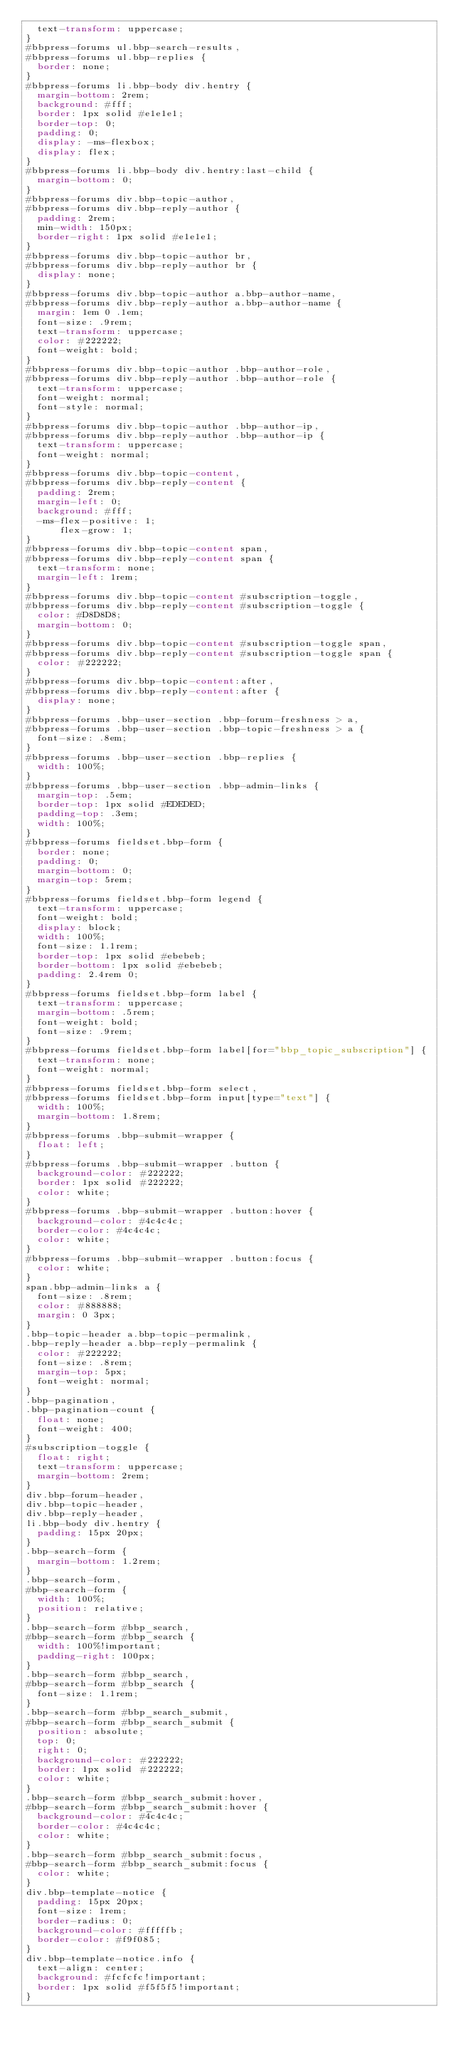<code> <loc_0><loc_0><loc_500><loc_500><_CSS_>  text-transform: uppercase;
}
#bbpress-forums ul.bbp-search-results,
#bbpress-forums ul.bbp-replies {
  border: none;
}
#bbpress-forums li.bbp-body div.hentry {
  margin-bottom: 2rem;
  background: #fff;
  border: 1px solid #e1e1e1;
  border-top: 0;
  padding: 0;
  display: -ms-flexbox;
  display: flex;
}
#bbpress-forums li.bbp-body div.hentry:last-child {
  margin-bottom: 0;
}
#bbpress-forums div.bbp-topic-author,
#bbpress-forums div.bbp-reply-author {
  padding: 2rem;
  min-width: 150px;
  border-right: 1px solid #e1e1e1;
}
#bbpress-forums div.bbp-topic-author br,
#bbpress-forums div.bbp-reply-author br {
  display: none;
}
#bbpress-forums div.bbp-topic-author a.bbp-author-name,
#bbpress-forums div.bbp-reply-author a.bbp-author-name {
  margin: 1em 0 .1em;
  font-size: .9rem;
  text-transform: uppercase;
  color: #222222;
  font-weight: bold;
}
#bbpress-forums div.bbp-topic-author .bbp-author-role,
#bbpress-forums div.bbp-reply-author .bbp-author-role {
  text-transform: uppercase;
  font-weight: normal;
  font-style: normal;
}
#bbpress-forums div.bbp-topic-author .bbp-author-ip,
#bbpress-forums div.bbp-reply-author .bbp-author-ip {
  text-transform: uppercase;
  font-weight: normal;
}
#bbpress-forums div.bbp-topic-content,
#bbpress-forums div.bbp-reply-content {
  padding: 2rem;
  margin-left: 0;
  background: #fff;
  -ms-flex-positive: 1;
      flex-grow: 1;
}
#bbpress-forums div.bbp-topic-content span,
#bbpress-forums div.bbp-reply-content span {
  text-transform: none;
  margin-left: 1rem;
}
#bbpress-forums div.bbp-topic-content #subscription-toggle,
#bbpress-forums div.bbp-reply-content #subscription-toggle {
  color: #D8D8D8;
  margin-bottom: 0;
}
#bbpress-forums div.bbp-topic-content #subscription-toggle span,
#bbpress-forums div.bbp-reply-content #subscription-toggle span {
  color: #222222;
}
#bbpress-forums div.bbp-topic-content:after,
#bbpress-forums div.bbp-reply-content:after {
  display: none;
}
#bbpress-forums .bbp-user-section .bbp-forum-freshness > a,
#bbpress-forums .bbp-user-section .bbp-topic-freshness > a {
  font-size: .8em;
}
#bbpress-forums .bbp-user-section .bbp-replies {
  width: 100%;
}
#bbpress-forums .bbp-user-section .bbp-admin-links {
  margin-top: .5em;
  border-top: 1px solid #EDEDED;
  padding-top: .3em;
  width: 100%;
}
#bbpress-forums fieldset.bbp-form {
  border: none;
  padding: 0;
  margin-bottom: 0;
  margin-top: 5rem;
}
#bbpress-forums fieldset.bbp-form legend {
  text-transform: uppercase;
  font-weight: bold;
  display: block;
  width: 100%;
  font-size: 1.1rem;
  border-top: 1px solid #ebebeb;
  border-bottom: 1px solid #ebebeb;
  padding: 2.4rem 0;
}
#bbpress-forums fieldset.bbp-form label {
  text-transform: uppercase;
  margin-bottom: .5rem;
  font-weight: bold;
  font-size: .9rem;
}
#bbpress-forums fieldset.bbp-form label[for="bbp_topic_subscription"] {
  text-transform: none;
  font-weight: normal;
}
#bbpress-forums fieldset.bbp-form select,
#bbpress-forums fieldset.bbp-form input[type="text"] {
  width: 100%;
  margin-bottom: 1.8rem;
}
#bbpress-forums .bbp-submit-wrapper {
  float: left;
}
#bbpress-forums .bbp-submit-wrapper .button {
  background-color: #222222;
  border: 1px solid #222222;
  color: white;
}
#bbpress-forums .bbp-submit-wrapper .button:hover {
  background-color: #4c4c4c;
  border-color: #4c4c4c;
  color: white;
}
#bbpress-forums .bbp-submit-wrapper .button:focus {
  color: white;
}
span.bbp-admin-links a {
  font-size: .8rem;
  color: #888888;
  margin: 0 3px;
}
.bbp-topic-header a.bbp-topic-permalink,
.bbp-reply-header a.bbp-reply-permalink {
  color: #222222;
  font-size: .8rem;
  margin-top: 5px;
  font-weight: normal;
}
.bbp-pagination,
.bbp-pagination-count {
  float: none;
  font-weight: 400;
}
#subscription-toggle {
  float: right;
  text-transform: uppercase;
  margin-bottom: 2rem;
}
div.bbp-forum-header,
div.bbp-topic-header,
div.bbp-reply-header,
li.bbp-body div.hentry {
  padding: 15px 20px;
}
.bbp-search-form {
  margin-bottom: 1.2rem;
}
.bbp-search-form,
#bbp-search-form {
  width: 100%;
  position: relative;
}
.bbp-search-form #bbp_search,
#bbp-search-form #bbp_search {
  width: 100%!important;
  padding-right: 100px;
}
.bbp-search-form #bbp_search,
#bbp-search-form #bbp_search {
  font-size: 1.1rem;
}
.bbp-search-form #bbp_search_submit,
#bbp-search-form #bbp_search_submit {
  position: absolute;
  top: 0;
  right: 0;
  background-color: #222222;
  border: 1px solid #222222;
  color: white;
}
.bbp-search-form #bbp_search_submit:hover,
#bbp-search-form #bbp_search_submit:hover {
  background-color: #4c4c4c;
  border-color: #4c4c4c;
  color: white;
}
.bbp-search-form #bbp_search_submit:focus,
#bbp-search-form #bbp_search_submit:focus {
  color: white;
}
div.bbp-template-notice {
  padding: 15px 20px;
  font-size: 1rem;
  border-radius: 0;
  background-color: #fffffb;
  border-color: #f9f085;
}
div.bbp-template-notice.info {
  text-align: center;
  background: #fcfcfc!important;
  border: 1px solid #f5f5f5!important;
}</code> 